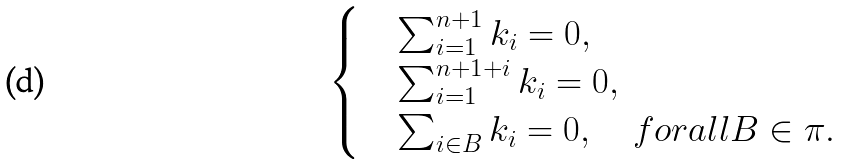<formula> <loc_0><loc_0><loc_500><loc_500>\begin{cases} & \sum _ { i = 1 } ^ { n + 1 } k _ { i } = 0 , \\ & \sum _ { i = 1 } ^ { n + 1 + i } k _ { i } = 0 , \\ & \sum _ { i \in B } k _ { i } = 0 , \quad f o r a l l B \in \pi . \end{cases}</formula> 